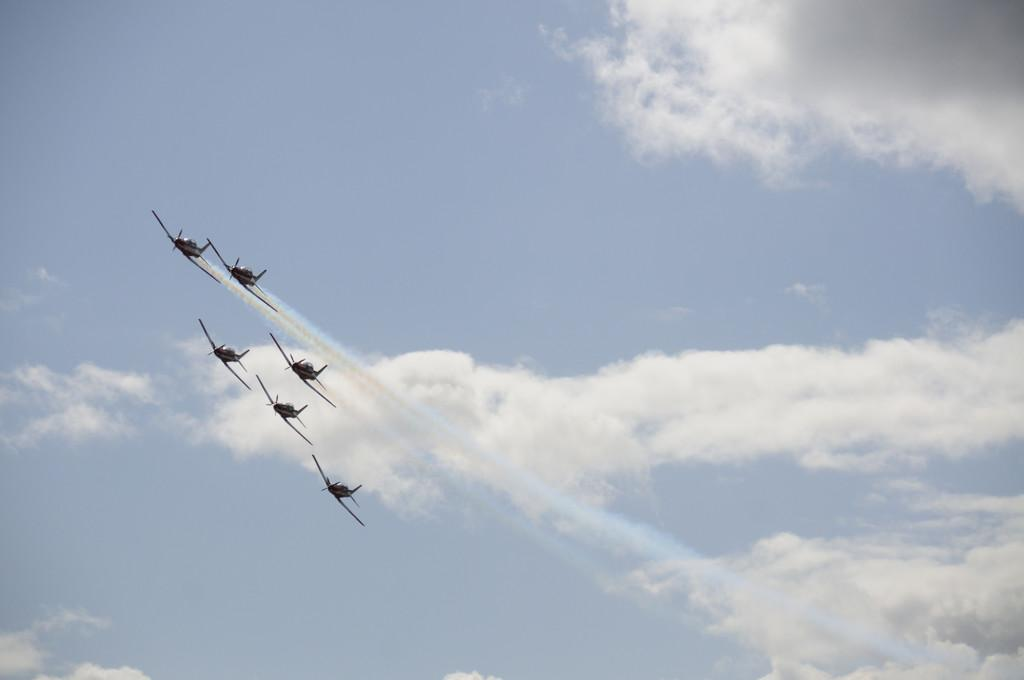What is happening in the sky in the image? There are planes flying in the sky. In which direction are the planes flying? The planes are flying towards the left. What can be seen in the background of the image? There is a sky visible in the image. What is the condition of the sky in the image? Clouds are present in the sky. Where is the town located in the image? There is no town present in the image; it only features planes flying in the sky. What type of hose can be seen connected to the top of the plane? There is no hose visible in the image; only planes flying in the sky are present. 